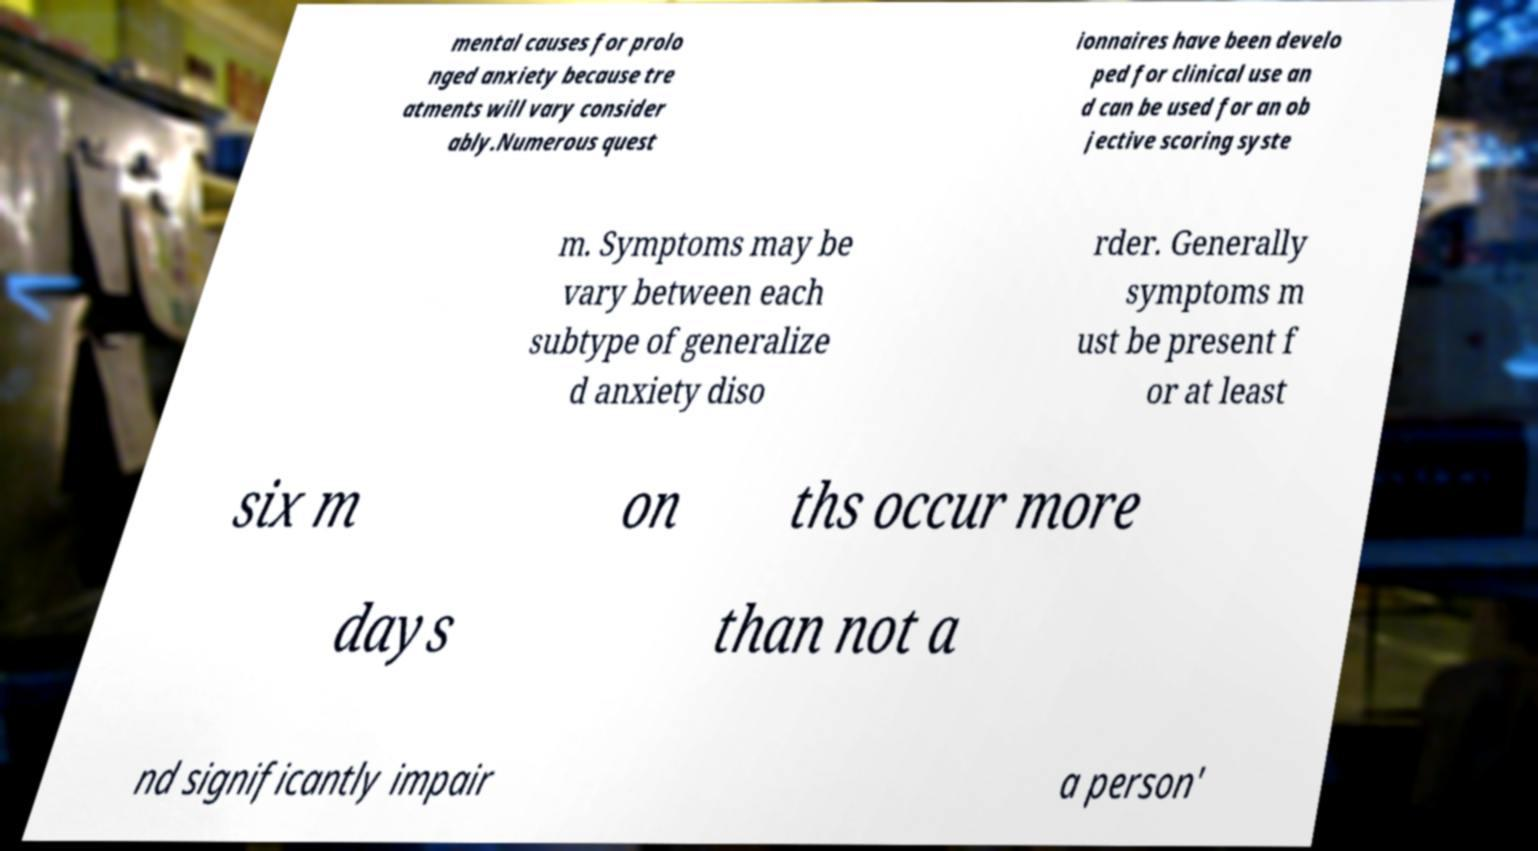Please read and relay the text visible in this image. What does it say? mental causes for prolo nged anxiety because tre atments will vary consider ably.Numerous quest ionnaires have been develo ped for clinical use an d can be used for an ob jective scoring syste m. Symptoms may be vary between each subtype of generalize d anxiety diso rder. Generally symptoms m ust be present f or at least six m on ths occur more days than not a nd significantly impair a person' 